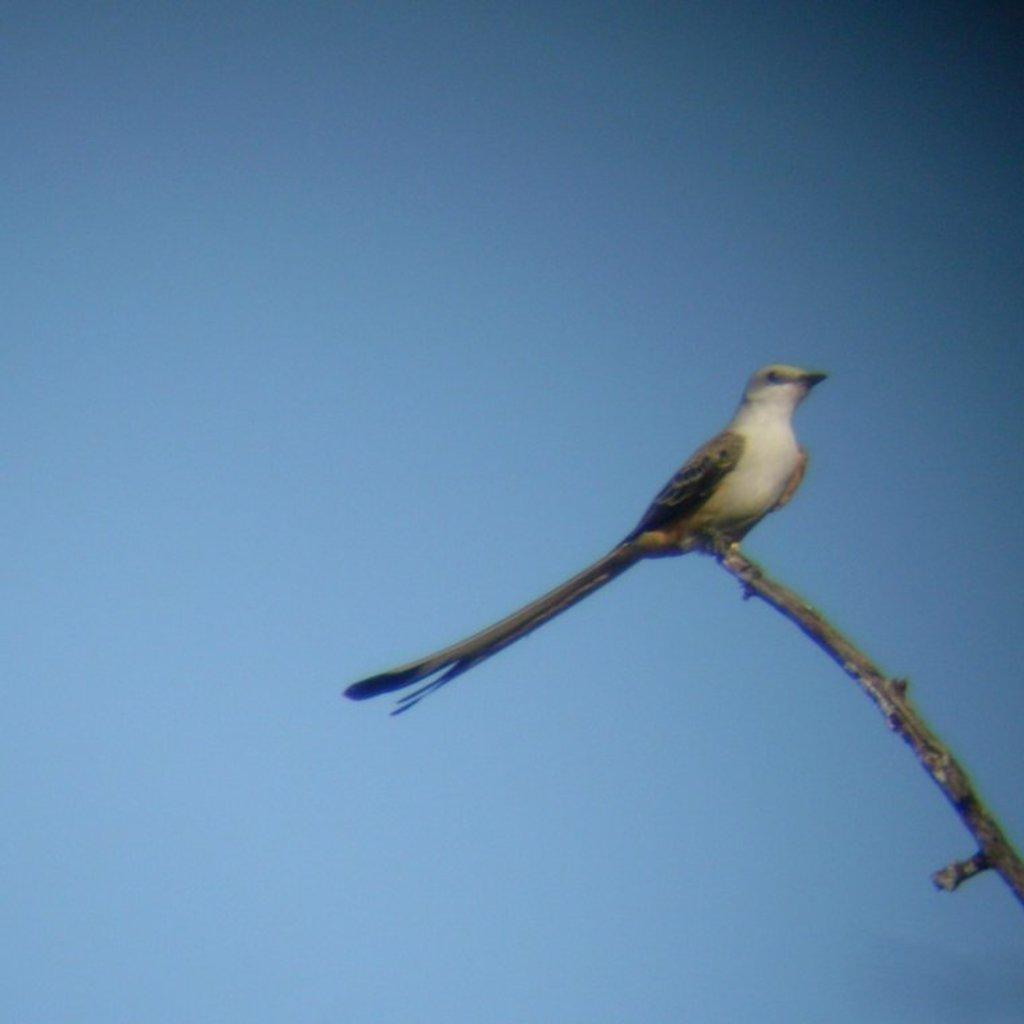What type of animal can be seen in the image? There is a bird in the image. Where is the bird located? The bird is on a branch of a tree. What can be seen in the background of the image? The sky is visible in the background of the image. How would you describe the weather based on the sky in the image? The sky appears to be cloudy, which might suggest overcast or potentially rainy weather. What type of coat is the bird wearing in the image? The bird is not wearing a coat in the image; birds do not wear clothing. 